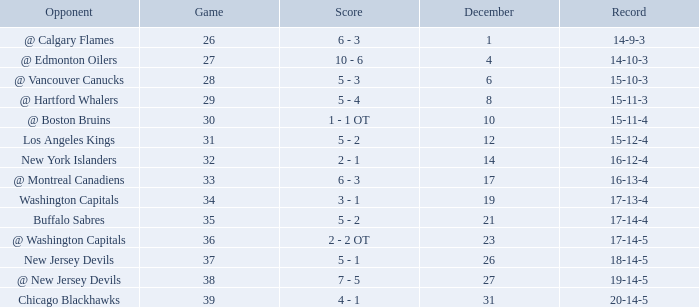Game larger than 34, and a December smaller than 23 had what record? 17-14-4. 